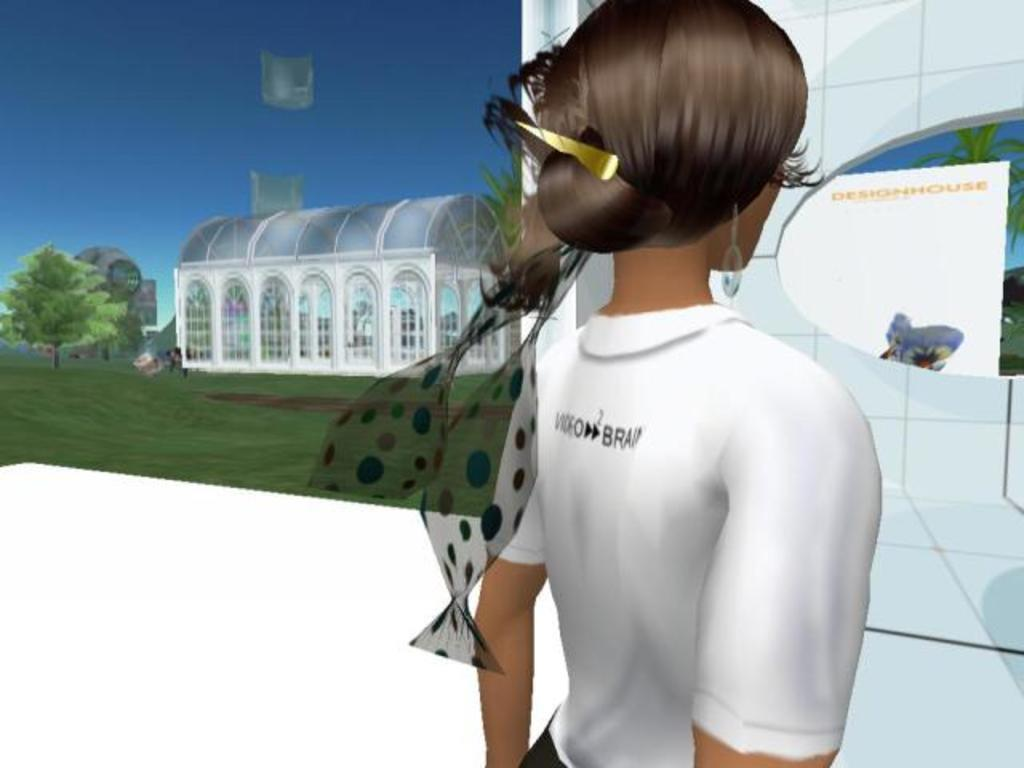Who or what is present in the image? There is a person in the image. What type of structure can be seen in the image? There is a house in the image. What type of vegetation is visible in the image? There are trees and grass in the image. What other items can be seen in the image? There are some objects in the image. What is visible in the background of the image? The sky is visible in the image. What type of soup is being served in the image? There is no soup present in the image. How many boys are visible in the image? The image does not show any boys; it only features a person. 